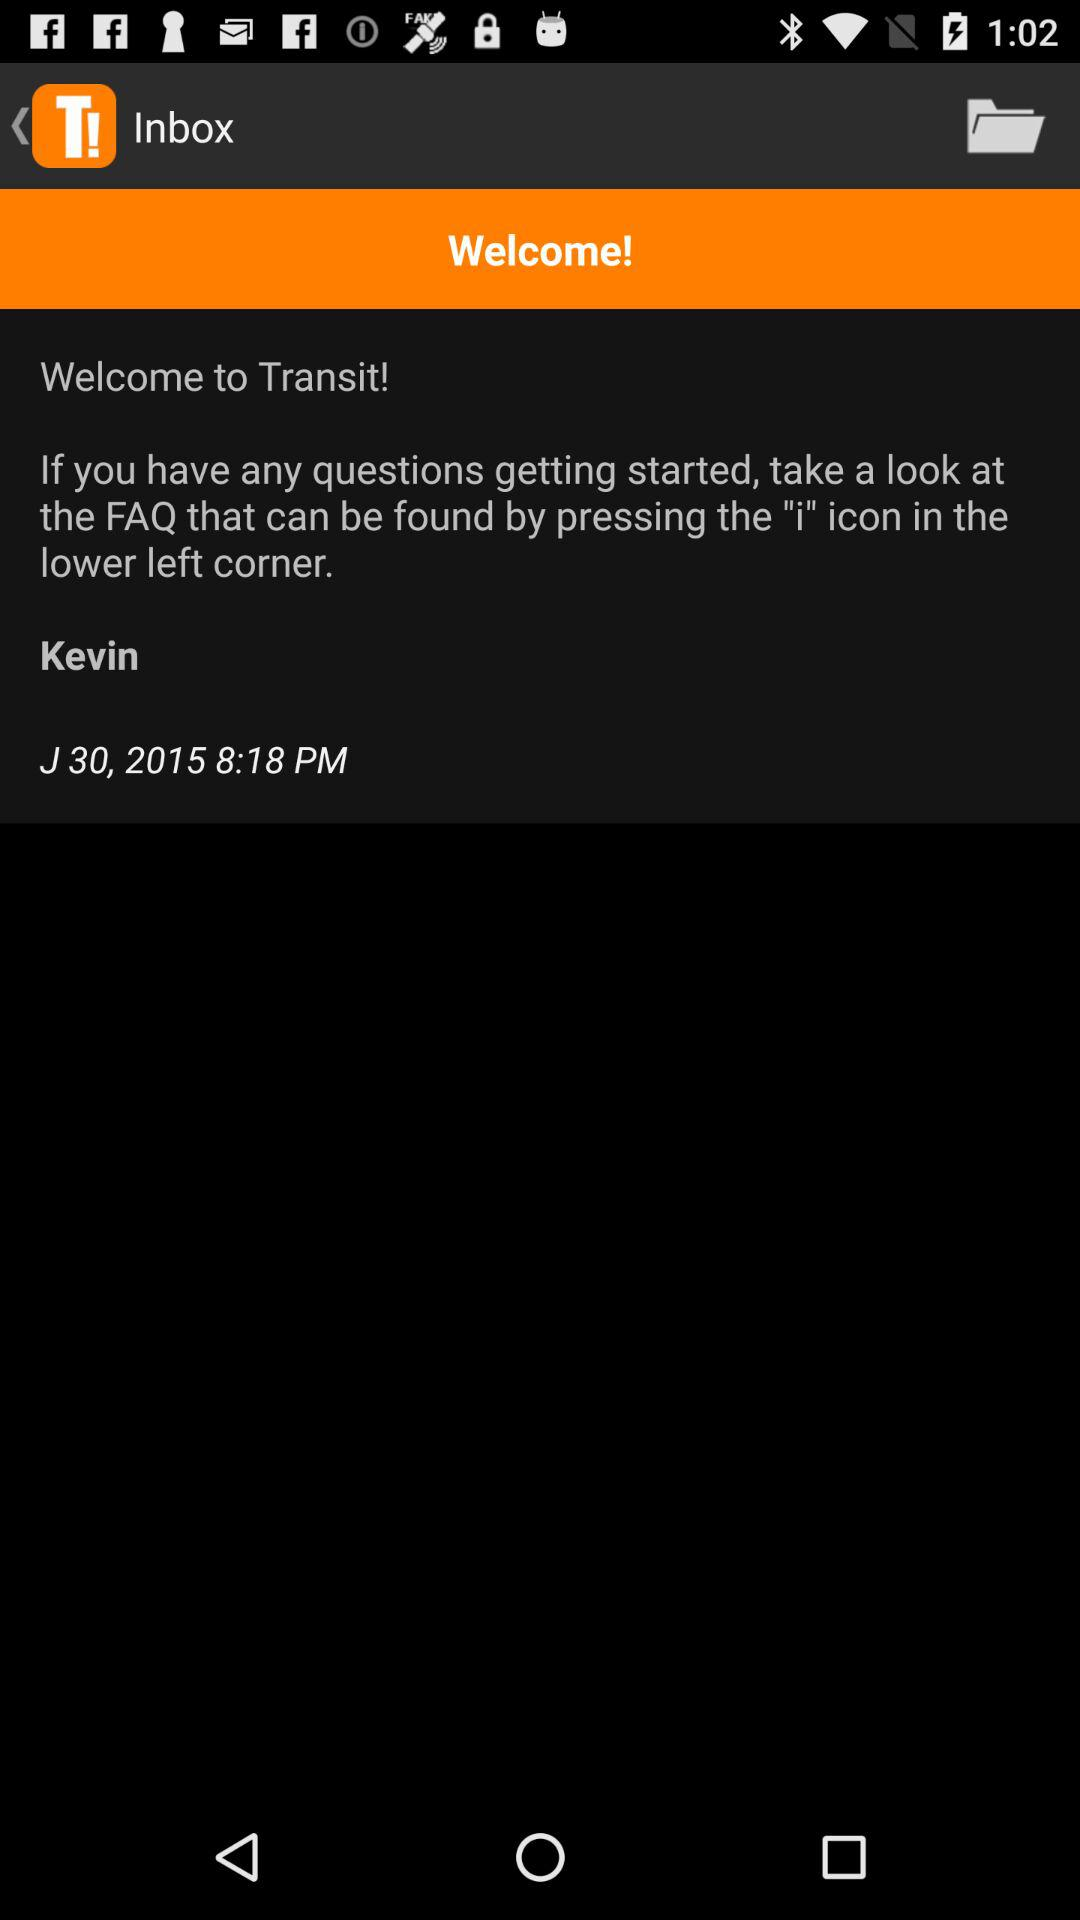What is the time of the message? The time of the message is 8:18 PM. 